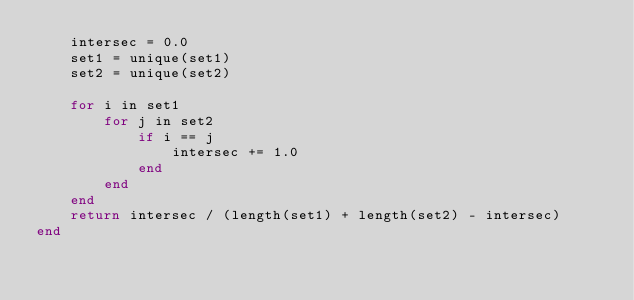Convert code to text. <code><loc_0><loc_0><loc_500><loc_500><_Julia_>    intersec = 0.0
    set1 = unique(set1)
    set2 = unique(set2)

    for i in set1
        for j in set2
            if i == j
                intersec += 1.0
            end
        end
    end
    return intersec / (length(set1) + length(set2) - intersec)
end
</code> 